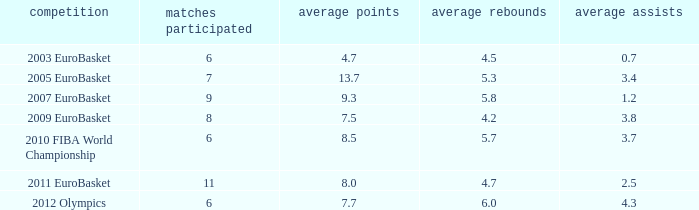How many games played have 4.7 points per game? 1.0. 